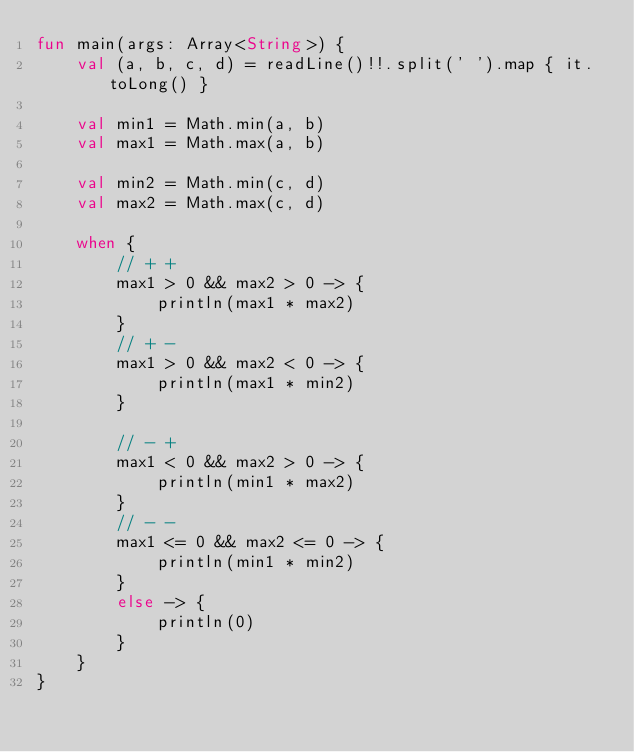<code> <loc_0><loc_0><loc_500><loc_500><_Kotlin_>fun main(args: Array<String>) {
    val (a, b, c, d) = readLine()!!.split(' ').map { it.toLong() }

    val min1 = Math.min(a, b)
    val max1 = Math.max(a, b)

    val min2 = Math.min(c, d)
    val max2 = Math.max(c, d)

    when {
        // + +
        max1 > 0 && max2 > 0 -> {
            println(max1 * max2)
        }
        // + -
        max1 > 0 && max2 < 0 -> {
            println(max1 * min2)
        }

        // - +
        max1 < 0 && max2 > 0 -> {
            println(min1 * max2)
        }
        // - -
        max1 <= 0 && max2 <= 0 -> {
            println(min1 * min2)
        }
        else -> {
            println(0)
        }
    }
}
</code> 